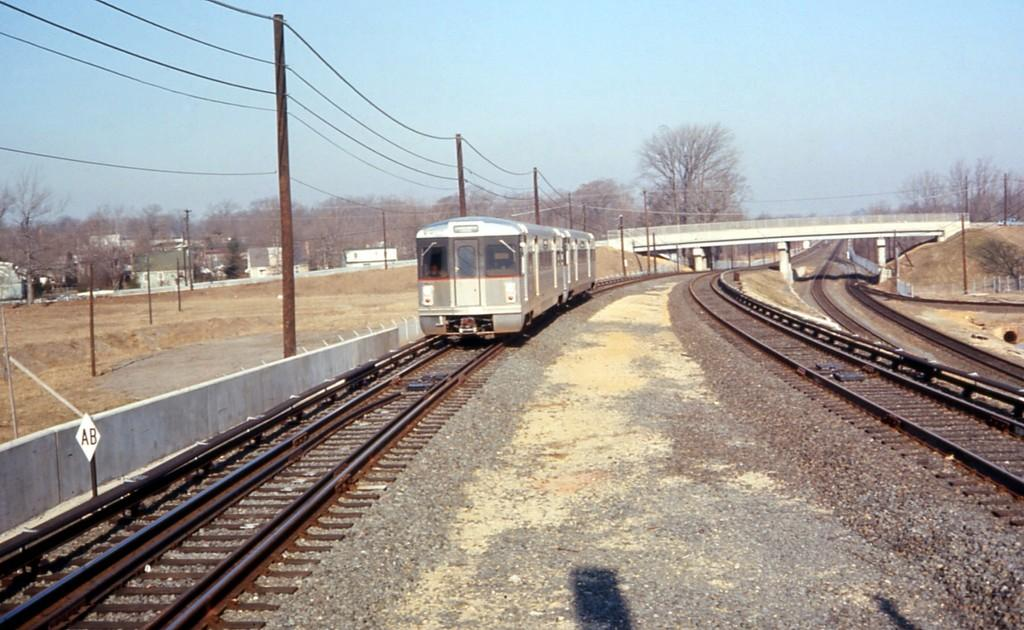What is the main subject of the image? The main subject of the image is a train. Where is the train located in the image? The train is on a railway track. What can be seen on the left side of the image? There are electric poles and wires on the left side of the image. What is visible in the background of the image? There is a bridge and trees in the background of the image. What is visible at the top of the image? The sky is visible at the top of the image. What type of sheet is covering the train in the image? There is no sheet covering the train in the image; it is on a railway track without any covering. How many cards are visible on the train in the image? There are no cards visible on the train in the image. 